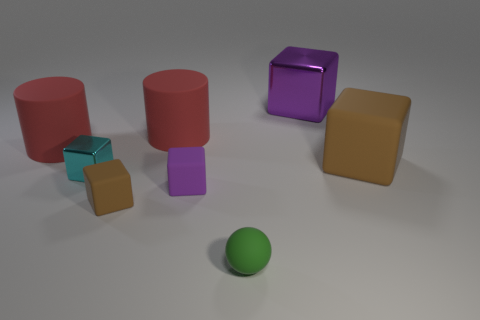Subtract 1 blocks. How many blocks are left? 4 Subtract all yellow blocks. Subtract all blue cylinders. How many blocks are left? 5 Subtract all spheres. How many objects are left? 7 Subtract all big brown matte things. Subtract all rubber balls. How many objects are left? 6 Add 4 tiny brown cubes. How many tiny brown cubes are left? 5 Add 7 cylinders. How many cylinders exist? 9 Subtract 1 cyan blocks. How many objects are left? 7 